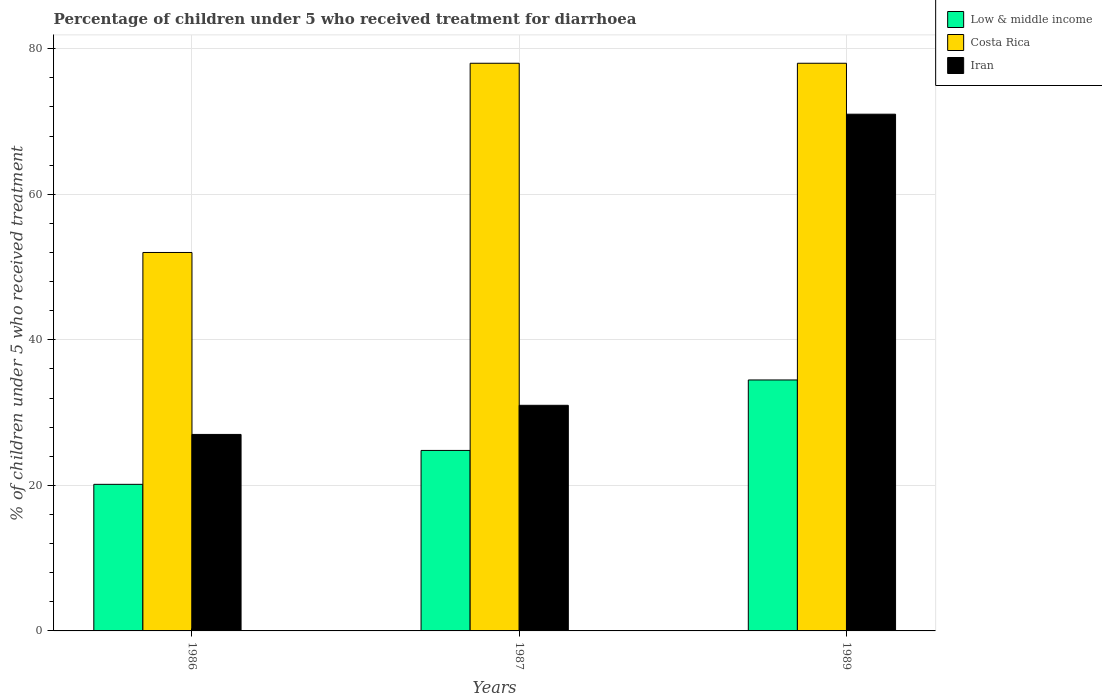How many bars are there on the 3rd tick from the left?
Give a very brief answer. 3. How many bars are there on the 3rd tick from the right?
Your response must be concise. 3. In how many cases, is the number of bars for a given year not equal to the number of legend labels?
Keep it short and to the point. 0. What is the percentage of children who received treatment for diarrhoea  in Low & middle income in 1986?
Provide a succinct answer. 20.14. Across all years, what is the maximum percentage of children who received treatment for diarrhoea  in Iran?
Provide a succinct answer. 71. Across all years, what is the minimum percentage of children who received treatment for diarrhoea  in Iran?
Your answer should be very brief. 27. What is the total percentage of children who received treatment for diarrhoea  in Low & middle income in the graph?
Make the answer very short. 79.42. What is the difference between the percentage of children who received treatment for diarrhoea  in Costa Rica in 1987 and that in 1989?
Make the answer very short. 0. What is the difference between the percentage of children who received treatment for diarrhoea  in Iran in 1986 and the percentage of children who received treatment for diarrhoea  in Costa Rica in 1989?
Ensure brevity in your answer.  -51. What is the average percentage of children who received treatment for diarrhoea  in Low & middle income per year?
Keep it short and to the point. 26.47. In how many years, is the percentage of children who received treatment for diarrhoea  in Low & middle income greater than 4 %?
Give a very brief answer. 3. What is the ratio of the percentage of children who received treatment for diarrhoea  in Low & middle income in 1987 to that in 1989?
Ensure brevity in your answer.  0.72. What is the difference between the highest and the second highest percentage of children who received treatment for diarrhoea  in Iran?
Provide a succinct answer. 40. What is the difference between the highest and the lowest percentage of children who received treatment for diarrhoea  in Costa Rica?
Ensure brevity in your answer.  26. In how many years, is the percentage of children who received treatment for diarrhoea  in Low & middle income greater than the average percentage of children who received treatment for diarrhoea  in Low & middle income taken over all years?
Your answer should be very brief. 1. Is the sum of the percentage of children who received treatment for diarrhoea  in Low & middle income in 1986 and 1989 greater than the maximum percentage of children who received treatment for diarrhoea  in Costa Rica across all years?
Offer a terse response. No. What does the 3rd bar from the left in 1986 represents?
Your answer should be very brief. Iran. What does the 2nd bar from the right in 1986 represents?
Provide a succinct answer. Costa Rica. Is it the case that in every year, the sum of the percentage of children who received treatment for diarrhoea  in Costa Rica and percentage of children who received treatment for diarrhoea  in Low & middle income is greater than the percentage of children who received treatment for diarrhoea  in Iran?
Offer a terse response. Yes. Are all the bars in the graph horizontal?
Your answer should be compact. No. What is the difference between two consecutive major ticks on the Y-axis?
Keep it short and to the point. 20. Are the values on the major ticks of Y-axis written in scientific E-notation?
Keep it short and to the point. No. Does the graph contain grids?
Provide a short and direct response. Yes. Where does the legend appear in the graph?
Keep it short and to the point. Top right. How many legend labels are there?
Your answer should be compact. 3. How are the legend labels stacked?
Make the answer very short. Vertical. What is the title of the graph?
Provide a short and direct response. Percentage of children under 5 who received treatment for diarrhoea. Does "Faeroe Islands" appear as one of the legend labels in the graph?
Your answer should be very brief. No. What is the label or title of the Y-axis?
Offer a very short reply. % of children under 5 who received treatment. What is the % of children under 5 who received treatment of Low & middle income in 1986?
Offer a very short reply. 20.14. What is the % of children under 5 who received treatment of Costa Rica in 1986?
Your response must be concise. 52. What is the % of children under 5 who received treatment in Low & middle income in 1987?
Your answer should be very brief. 24.8. What is the % of children under 5 who received treatment of Costa Rica in 1987?
Your answer should be compact. 78. What is the % of children under 5 who received treatment of Low & middle income in 1989?
Your answer should be very brief. 34.48. What is the % of children under 5 who received treatment in Costa Rica in 1989?
Your answer should be very brief. 78. Across all years, what is the maximum % of children under 5 who received treatment in Low & middle income?
Your answer should be very brief. 34.48. Across all years, what is the maximum % of children under 5 who received treatment in Costa Rica?
Make the answer very short. 78. Across all years, what is the minimum % of children under 5 who received treatment of Low & middle income?
Provide a short and direct response. 20.14. Across all years, what is the minimum % of children under 5 who received treatment in Costa Rica?
Offer a terse response. 52. What is the total % of children under 5 who received treatment in Low & middle income in the graph?
Give a very brief answer. 79.42. What is the total % of children under 5 who received treatment in Costa Rica in the graph?
Provide a succinct answer. 208. What is the total % of children under 5 who received treatment in Iran in the graph?
Provide a short and direct response. 129. What is the difference between the % of children under 5 who received treatment of Low & middle income in 1986 and that in 1987?
Make the answer very short. -4.66. What is the difference between the % of children under 5 who received treatment in Costa Rica in 1986 and that in 1987?
Provide a short and direct response. -26. What is the difference between the % of children under 5 who received treatment in Low & middle income in 1986 and that in 1989?
Your answer should be very brief. -14.34. What is the difference between the % of children under 5 who received treatment of Costa Rica in 1986 and that in 1989?
Offer a very short reply. -26. What is the difference between the % of children under 5 who received treatment of Iran in 1986 and that in 1989?
Keep it short and to the point. -44. What is the difference between the % of children under 5 who received treatment in Low & middle income in 1987 and that in 1989?
Offer a very short reply. -9.68. What is the difference between the % of children under 5 who received treatment of Costa Rica in 1987 and that in 1989?
Ensure brevity in your answer.  0. What is the difference between the % of children under 5 who received treatment of Low & middle income in 1986 and the % of children under 5 who received treatment of Costa Rica in 1987?
Offer a terse response. -57.86. What is the difference between the % of children under 5 who received treatment of Low & middle income in 1986 and the % of children under 5 who received treatment of Iran in 1987?
Make the answer very short. -10.86. What is the difference between the % of children under 5 who received treatment in Low & middle income in 1986 and the % of children under 5 who received treatment in Costa Rica in 1989?
Your answer should be very brief. -57.86. What is the difference between the % of children under 5 who received treatment in Low & middle income in 1986 and the % of children under 5 who received treatment in Iran in 1989?
Keep it short and to the point. -50.86. What is the difference between the % of children under 5 who received treatment in Costa Rica in 1986 and the % of children under 5 who received treatment in Iran in 1989?
Provide a short and direct response. -19. What is the difference between the % of children under 5 who received treatment in Low & middle income in 1987 and the % of children under 5 who received treatment in Costa Rica in 1989?
Make the answer very short. -53.2. What is the difference between the % of children under 5 who received treatment of Low & middle income in 1987 and the % of children under 5 who received treatment of Iran in 1989?
Ensure brevity in your answer.  -46.2. What is the difference between the % of children under 5 who received treatment of Costa Rica in 1987 and the % of children under 5 who received treatment of Iran in 1989?
Keep it short and to the point. 7. What is the average % of children under 5 who received treatment in Low & middle income per year?
Your response must be concise. 26.47. What is the average % of children under 5 who received treatment in Costa Rica per year?
Your response must be concise. 69.33. In the year 1986, what is the difference between the % of children under 5 who received treatment of Low & middle income and % of children under 5 who received treatment of Costa Rica?
Give a very brief answer. -31.86. In the year 1986, what is the difference between the % of children under 5 who received treatment of Low & middle income and % of children under 5 who received treatment of Iran?
Make the answer very short. -6.86. In the year 1986, what is the difference between the % of children under 5 who received treatment in Costa Rica and % of children under 5 who received treatment in Iran?
Your answer should be compact. 25. In the year 1987, what is the difference between the % of children under 5 who received treatment in Low & middle income and % of children under 5 who received treatment in Costa Rica?
Provide a short and direct response. -53.2. In the year 1987, what is the difference between the % of children under 5 who received treatment in Low & middle income and % of children under 5 who received treatment in Iran?
Your response must be concise. -6.2. In the year 1987, what is the difference between the % of children under 5 who received treatment of Costa Rica and % of children under 5 who received treatment of Iran?
Your answer should be very brief. 47. In the year 1989, what is the difference between the % of children under 5 who received treatment in Low & middle income and % of children under 5 who received treatment in Costa Rica?
Make the answer very short. -43.52. In the year 1989, what is the difference between the % of children under 5 who received treatment of Low & middle income and % of children under 5 who received treatment of Iran?
Ensure brevity in your answer.  -36.52. In the year 1989, what is the difference between the % of children under 5 who received treatment in Costa Rica and % of children under 5 who received treatment in Iran?
Make the answer very short. 7. What is the ratio of the % of children under 5 who received treatment of Low & middle income in 1986 to that in 1987?
Your answer should be compact. 0.81. What is the ratio of the % of children under 5 who received treatment of Iran in 1986 to that in 1987?
Make the answer very short. 0.87. What is the ratio of the % of children under 5 who received treatment of Low & middle income in 1986 to that in 1989?
Your response must be concise. 0.58. What is the ratio of the % of children under 5 who received treatment in Costa Rica in 1986 to that in 1989?
Keep it short and to the point. 0.67. What is the ratio of the % of children under 5 who received treatment in Iran in 1986 to that in 1989?
Your answer should be compact. 0.38. What is the ratio of the % of children under 5 who received treatment in Low & middle income in 1987 to that in 1989?
Make the answer very short. 0.72. What is the ratio of the % of children under 5 who received treatment of Iran in 1987 to that in 1989?
Provide a succinct answer. 0.44. What is the difference between the highest and the second highest % of children under 5 who received treatment in Low & middle income?
Keep it short and to the point. 9.68. What is the difference between the highest and the second highest % of children under 5 who received treatment of Iran?
Make the answer very short. 40. What is the difference between the highest and the lowest % of children under 5 who received treatment of Low & middle income?
Your answer should be very brief. 14.34. What is the difference between the highest and the lowest % of children under 5 who received treatment in Costa Rica?
Your answer should be compact. 26. 